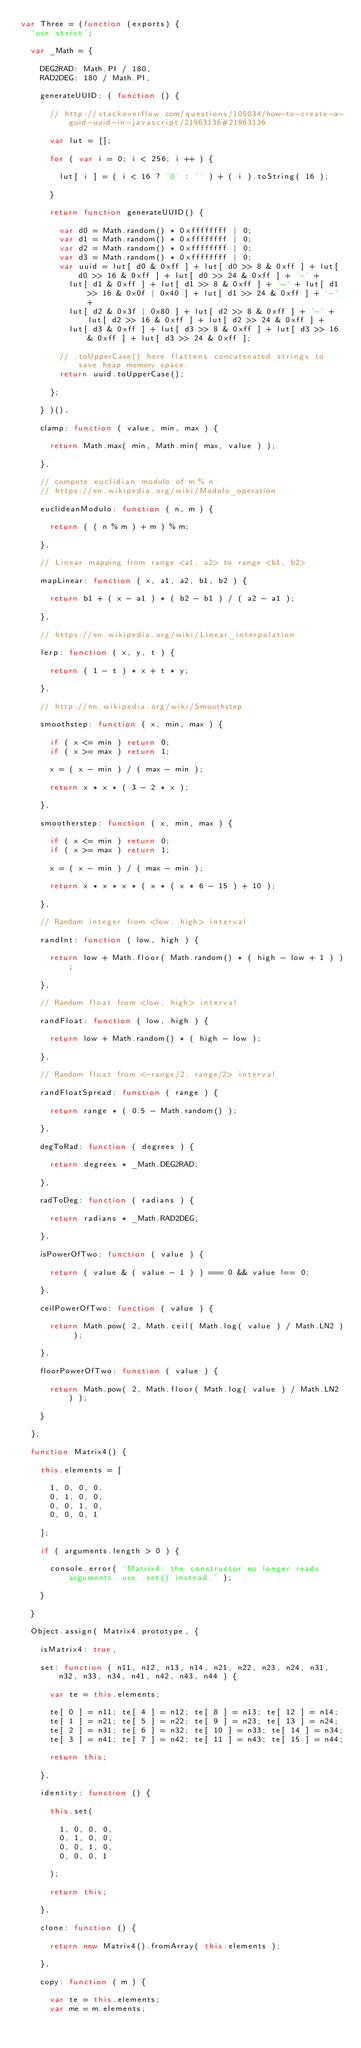<code> <loc_0><loc_0><loc_500><loc_500><_JavaScript_>var Three = (function (exports) {
	'use strict';

	var _Math = {

		DEG2RAD: Math.PI / 180,
		RAD2DEG: 180 / Math.PI,

		generateUUID: ( function () {

			// http://stackoverflow.com/questions/105034/how-to-create-a-guid-uuid-in-javascript/21963136#21963136

			var lut = [];

			for ( var i = 0; i < 256; i ++ ) {

				lut[ i ] = ( i < 16 ? '0' : '' ) + ( i ).toString( 16 );

			}

			return function generateUUID() {

				var d0 = Math.random() * 0xffffffff | 0;
				var d1 = Math.random() * 0xffffffff | 0;
				var d2 = Math.random() * 0xffffffff | 0;
				var d3 = Math.random() * 0xffffffff | 0;
				var uuid = lut[ d0 & 0xff ] + lut[ d0 >> 8 & 0xff ] + lut[ d0 >> 16 & 0xff ] + lut[ d0 >> 24 & 0xff ] + '-' +
					lut[ d1 & 0xff ] + lut[ d1 >> 8 & 0xff ] + '-' + lut[ d1 >> 16 & 0x0f | 0x40 ] + lut[ d1 >> 24 & 0xff ] + '-' +
					lut[ d2 & 0x3f | 0x80 ] + lut[ d2 >> 8 & 0xff ] + '-' + lut[ d2 >> 16 & 0xff ] + lut[ d2 >> 24 & 0xff ] +
					lut[ d3 & 0xff ] + lut[ d3 >> 8 & 0xff ] + lut[ d3 >> 16 & 0xff ] + lut[ d3 >> 24 & 0xff ];

				// .toUpperCase() here flattens concatenated strings to save heap memory space.
				return uuid.toUpperCase();

			};

		} )(),

		clamp: function ( value, min, max ) {

			return Math.max( min, Math.min( max, value ) );

		},

		// compute euclidian modulo of m % n
		// https://en.wikipedia.org/wiki/Modulo_operation

		euclideanModulo: function ( n, m ) {

			return ( ( n % m ) + m ) % m;

		},

		// Linear mapping from range <a1, a2> to range <b1, b2>

		mapLinear: function ( x, a1, a2, b1, b2 ) {

			return b1 + ( x - a1 ) * ( b2 - b1 ) / ( a2 - a1 );

		},

		// https://en.wikipedia.org/wiki/Linear_interpolation

		lerp: function ( x, y, t ) {

			return ( 1 - t ) * x + t * y;

		},

		// http://en.wikipedia.org/wiki/Smoothstep

		smoothstep: function ( x, min, max ) {

			if ( x <= min ) return 0;
			if ( x >= max ) return 1;

			x = ( x - min ) / ( max - min );

			return x * x * ( 3 - 2 * x );

		},

		smootherstep: function ( x, min, max ) {

			if ( x <= min ) return 0;
			if ( x >= max ) return 1;

			x = ( x - min ) / ( max - min );

			return x * x * x * ( x * ( x * 6 - 15 ) + 10 );

		},

		// Random integer from <low, high> interval

		randInt: function ( low, high ) {

			return low + Math.floor( Math.random() * ( high - low + 1 ) );

		},

		// Random float from <low, high> interval

		randFloat: function ( low, high ) {

			return low + Math.random() * ( high - low );

		},

		// Random float from <-range/2, range/2> interval

		randFloatSpread: function ( range ) {

			return range * ( 0.5 - Math.random() );

		},

		degToRad: function ( degrees ) {

			return degrees * _Math.DEG2RAD;

		},

		radToDeg: function ( radians ) {

			return radians * _Math.RAD2DEG;

		},

		isPowerOfTwo: function ( value ) {

			return ( value & ( value - 1 ) ) === 0 && value !== 0;

		},

		ceilPowerOfTwo: function ( value ) {

			return Math.pow( 2, Math.ceil( Math.log( value ) / Math.LN2 ) );

		},

		floorPowerOfTwo: function ( value ) {

			return Math.pow( 2, Math.floor( Math.log( value ) / Math.LN2 ) );

		}

	};

	function Matrix4() {

		this.elements = [

			1, 0, 0, 0,
			0, 1, 0, 0,
			0, 0, 1, 0,
			0, 0, 0, 1

		];

		if ( arguments.length > 0 ) {

			console.error( 'Matrix4: the constructor no longer reads arguments. use .set() instead.' );

		}

	}

	Object.assign( Matrix4.prototype, {

		isMatrix4: true,

		set: function ( n11, n12, n13, n14, n21, n22, n23, n24, n31, n32, n33, n34, n41, n42, n43, n44 ) {

			var te = this.elements;

			te[ 0 ] = n11; te[ 4 ] = n12; te[ 8 ] = n13; te[ 12 ] = n14;
			te[ 1 ] = n21; te[ 5 ] = n22; te[ 9 ] = n23; te[ 13 ] = n24;
			te[ 2 ] = n31; te[ 6 ] = n32; te[ 10 ] = n33; te[ 14 ] = n34;
			te[ 3 ] = n41; te[ 7 ] = n42; te[ 11 ] = n43; te[ 15 ] = n44;

			return this;

		},

		identity: function () {

			this.set(

				1, 0, 0, 0,
				0, 1, 0, 0,
				0, 0, 1, 0,
				0, 0, 0, 1

			);

			return this;

		},

		clone: function () {

			return new Matrix4().fromArray( this.elements );

		},

		copy: function ( m ) {

			var te = this.elements;
			var me = m.elements;
</code> 